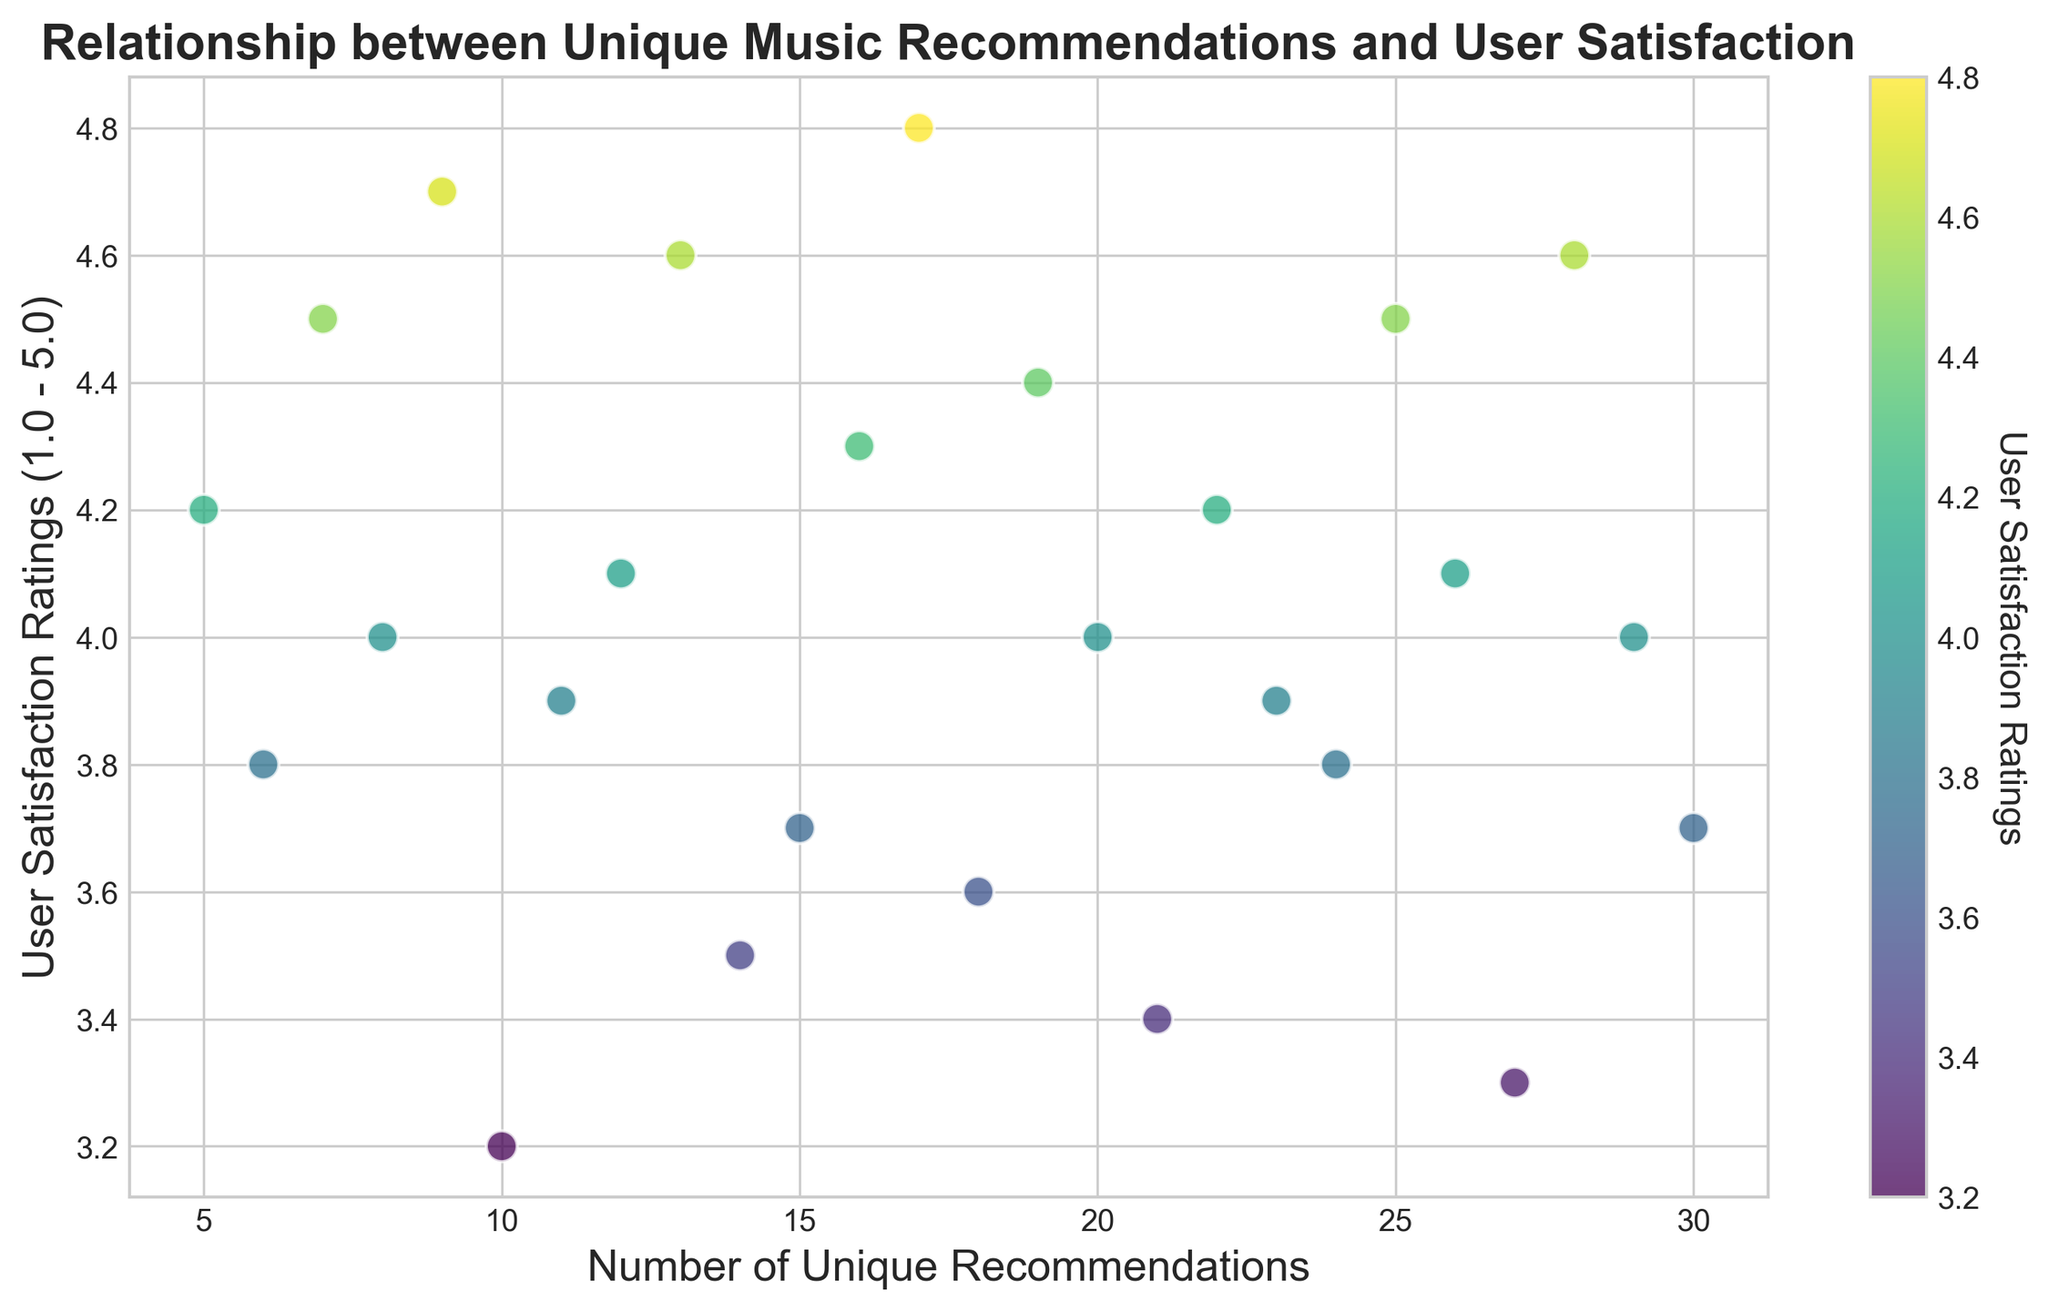What is the range of user satisfaction ratings displayed in the scatter plot? The lowest user satisfaction rating is 3.2 and the highest user satisfaction rating is 4.8. Therefore, the range is 4.8 - 3.2 = 1.6.
Answer: 1.6 How many unique recommendations correspond to the highest user satisfaction rating? The highest user satisfaction rating is 4.8, which corresponds to 17 unique recommendations.
Answer: 17 Is there a positive or negative correlation between the number of unique recommendations and user satisfaction ratings? By observing the scatter plot, we can see that user satisfaction ratings generally increase as the number of unique recommendations increases, suggesting a positive correlation.
Answer: Positive Which user satisfaction ratings fall between 4.0 and 4.5? The user satisfaction ratings in the range [4.0, 4.5] are: 4.0, 4.1, 4.2, 4.3, 4.4, 4.5. These correspond to unique recommendations of 8, 12, 22, 16, 19, and 7, respectively.
Answer: 4.0, 4.1, 4.2, 4.3, 4.4, 4.5 What are the unique recommendation values associated with user satisfaction ratings lower than 4.0? The user satisfaction ratings below 4.0 are: 3.8, 3.2, 3.9, 3.5, 3.7, 3.6, 3.4, 3.3. Corresponding unique recommendation values are: 6, 10, 11, 14, 15, 18, 21, 27.
Answer: 6, 10, 11, 14, 15, 18, 21, 27 What is the average number of unique recommendations for user satisfaction ratings of exactly 4.0? User satisfaction ratings of 4.0 correspond to unique recommendations of 8, 20, and 29. The average is (8 + 20 + 29) / 3 = 57 / 3 = 19.
Answer: 19 Among the points, which one has the maximum number of unique recommendations, and what is its user satisfaction rating? The maximum number of unique recommendations is 30, and the corresponding user satisfaction rating is 3.7.
Answer: 3.7 Which data point shows the lowest user satisfaction rating, and what is the number of unique recommendations associated with it? The lowest user satisfaction rating is 3.2, and it corresponds to 10 unique recommendations.
Answer: 10 